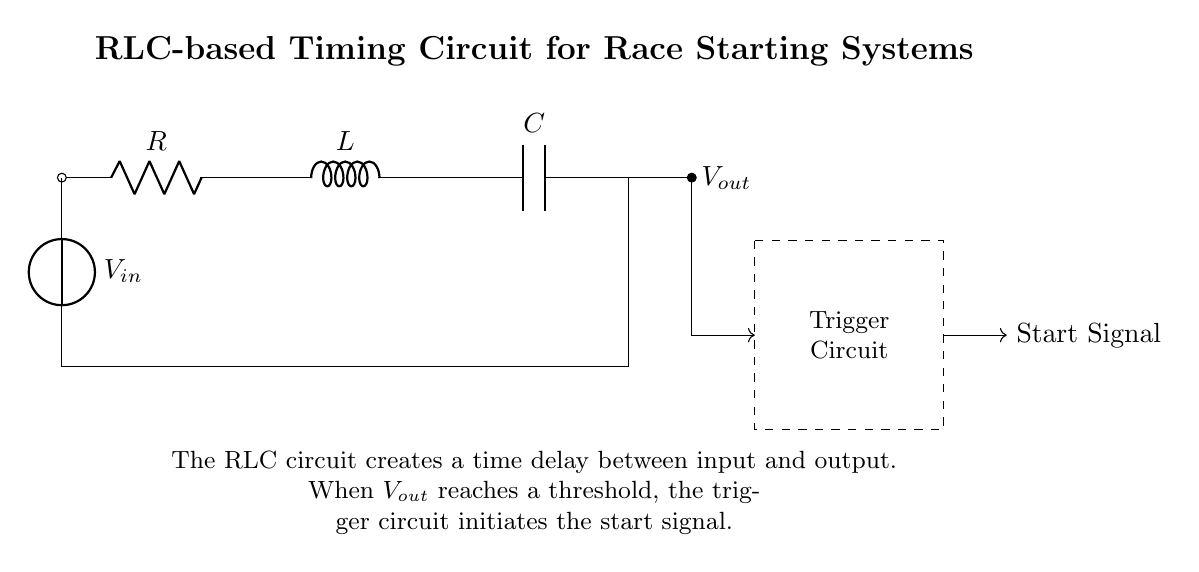What components are present in this circuit? The circuit contains a resistor, inductor, and capacitor, which are labeled R, L, and C respectively. These components are essential for creating the timing function of the circuit.
Answer: Resistor, Inductor, Capacitor What is the purpose of the trigger circuit? The trigger circuit is designed to generate a start signal when the output voltage reaches a specific threshold. This is a critical function to initiate timing in race starting systems.
Answer: Generate start signal What does the output voltage depend on? The output voltage depends on the values of the resistor, inductor, and capacitor, which together determine the time constant of the circuit. This time constant influences how quickly the output voltage reaches a threshold.
Answer: Resistor, Inductor, Capacitor values What is the function of the input voltage? The input voltage is the source that activates the RLC circuit, allowing the components to respond and generate the output voltage with a time delay for timing purposes.
Answer: Activate RLC circuit How is the start signal initiated? The start signal is initiated when the output voltage reaches a specified threshold, as detected by the trigger circuit, which connects from the output to the start signal line.
Answer: Output voltage threshold reached What type of circuit is this example? This is an RLC timing circuit, which utilizes the combination of resistor, inductor, and capacitor to create a controlled time delay for specific applications, such as race starts.
Answer: RLC timing circuit What happens if the values of R, L, or C change? Changing the values of R, L, or C will alter the time constant of the circuit, affecting how quickly the output voltage reaches the threshold needed to trigger the start signal.
Answer: Time constant alters 